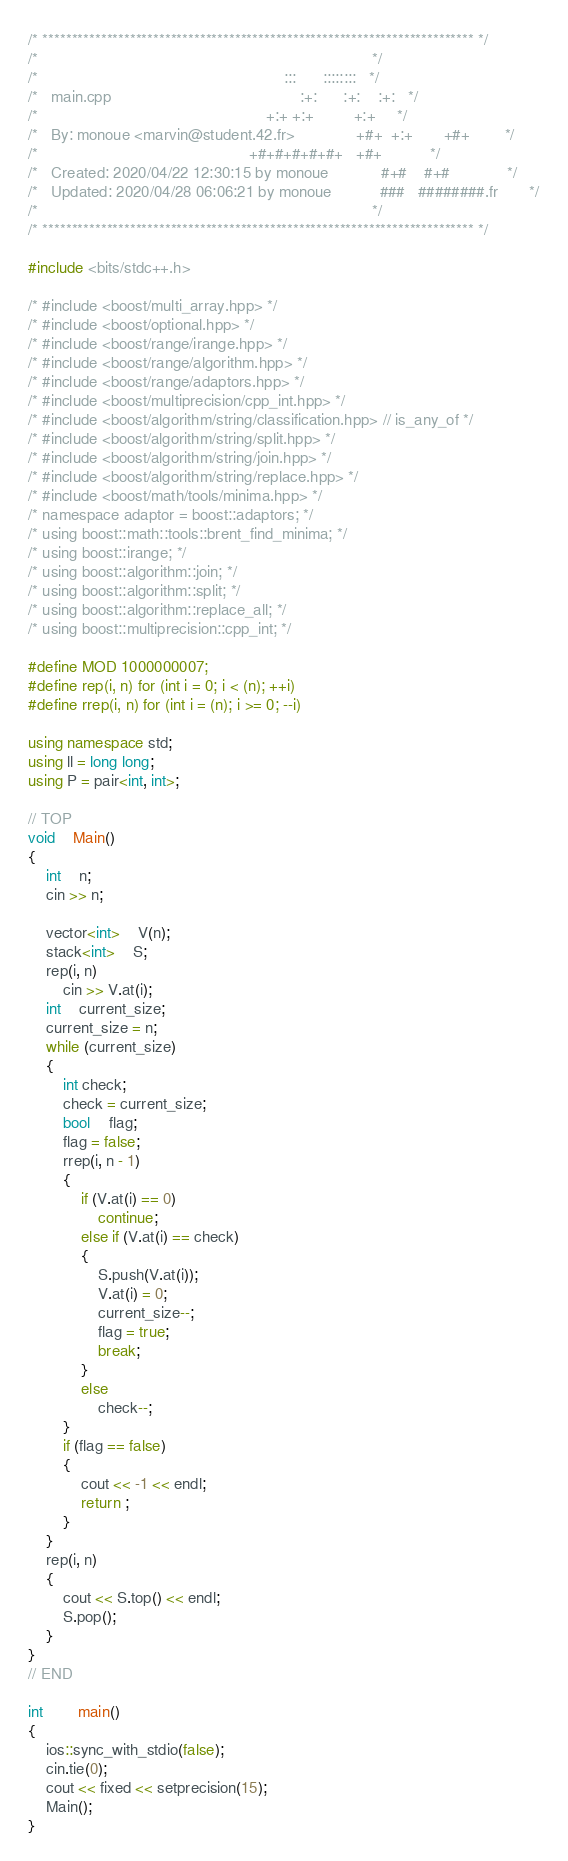Convert code to text. <code><loc_0><loc_0><loc_500><loc_500><_C++_>/* ************************************************************************** */
/*                                                                            */
/*                                                        :::      ::::::::   */
/*   main.cpp                                           :+:      :+:    :+:   */
/*                                                    +:+ +:+         +:+     */
/*   By: monoue <marvin@student.42.fr>              +#+  +:+       +#+        */
/*                                                +#+#+#+#+#+   +#+           */
/*   Created: 2020/04/22 12:30:15 by monoue            #+#    #+#             */
/*   Updated: 2020/04/28 06:06:21 by monoue           ###   ########.fr       */
/*                                                                            */
/* ************************************************************************** */

#include <bits/stdc++.h>

/* #include <boost/multi_array.hpp> */
/* #include <boost/optional.hpp> */
/* #include <boost/range/irange.hpp> */
/* #include <boost/range/algorithm.hpp> */
/* #include <boost/range/adaptors.hpp> */
/* #include <boost/multiprecision/cpp_int.hpp> */
/* #include <boost/algorithm/string/classification.hpp> // is_any_of */
/* #include <boost/algorithm/string/split.hpp> */
/* #include <boost/algorithm/string/join.hpp> */
/* #include <boost/algorithm/string/replace.hpp> */
/* #include <boost/math/tools/minima.hpp> */
/* namespace adaptor = boost::adaptors; */
/* using boost::math::tools::brent_find_minima; */
/* using boost::irange; */
/* using boost::algorithm::join; */
/* using boost::algorithm::split; */
/* using boost::algorithm::replace_all; */
/* using boost::multiprecision::cpp_int; */

#define MOD 1000000007;
#define rep(i, n) for (int i = 0; i < (n); ++i)
#define rrep(i, n) for (int i = (n); i >= 0; --i)

using namespace std;
using ll = long long;
using P = pair<int, int>;

// TOP
void	Main()
{
	int	n;
	cin >> n;

	vector<int>	V(n);
	stack<int>	S;
	rep(i, n)
		cin >> V.at(i);
	int	current_size;
	current_size = n;
	while (current_size)
	{
		int check;
		check = current_size;
		bool	flag;
		flag = false;
		rrep(i, n - 1)
		{
			if (V.at(i) == 0)
				continue;
			else if (V.at(i) == check)
			{
				S.push(V.at(i));
				V.at(i) = 0;
				current_size--;
				flag = true;
				break;
			}
			else
				check--;
		}
		if (flag == false)
		{
			cout << -1 << endl;
			return ;
		}
	}
	rep(i, n)
	{
		cout << S.top() << endl;
		S.pop();
	}
}
// END

int		main()
{
	ios::sync_with_stdio(false);
	cin.tie(0);
	cout << fixed << setprecision(15);
	Main();
}
</code> 